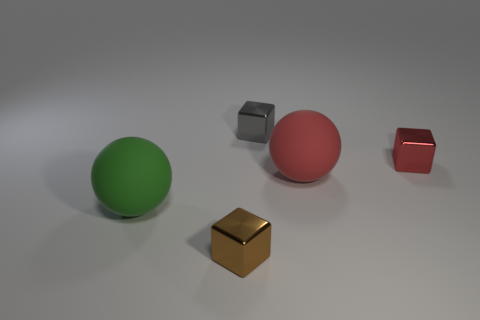Add 4 large yellow rubber cubes. How many objects exist? 9 Subtract all blocks. How many objects are left? 2 Add 5 green balls. How many green balls exist? 6 Subtract 0 blue blocks. How many objects are left? 5 Subtract all tiny brown objects. Subtract all gray blocks. How many objects are left? 3 Add 3 tiny metal cubes. How many tiny metal cubes are left? 6 